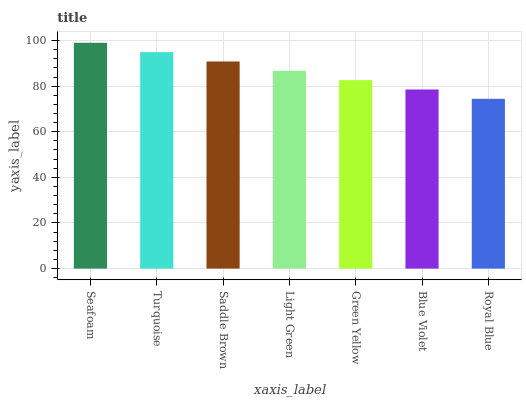Is Royal Blue the minimum?
Answer yes or no. Yes. Is Seafoam the maximum?
Answer yes or no. Yes. Is Turquoise the minimum?
Answer yes or no. No. Is Turquoise the maximum?
Answer yes or no. No. Is Seafoam greater than Turquoise?
Answer yes or no. Yes. Is Turquoise less than Seafoam?
Answer yes or no. Yes. Is Turquoise greater than Seafoam?
Answer yes or no. No. Is Seafoam less than Turquoise?
Answer yes or no. No. Is Light Green the high median?
Answer yes or no. Yes. Is Light Green the low median?
Answer yes or no. Yes. Is Turquoise the high median?
Answer yes or no. No. Is Seafoam the low median?
Answer yes or no. No. 